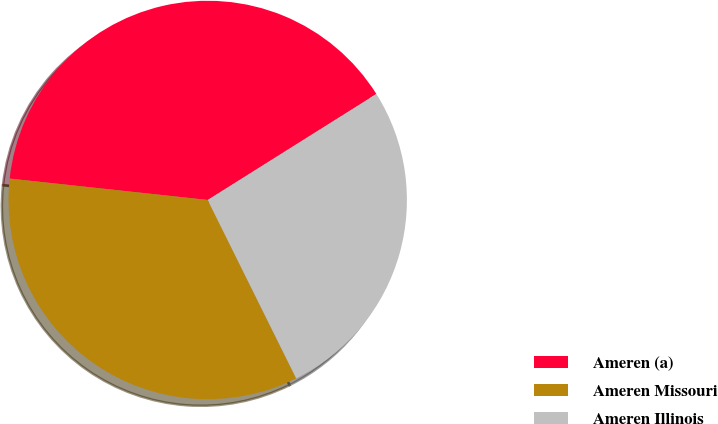Convert chart. <chart><loc_0><loc_0><loc_500><loc_500><pie_chart><fcel>Ameren (a)<fcel>Ameren Missouri<fcel>Ameren Illinois<nl><fcel>39.36%<fcel>34.04%<fcel>26.6%<nl></chart> 